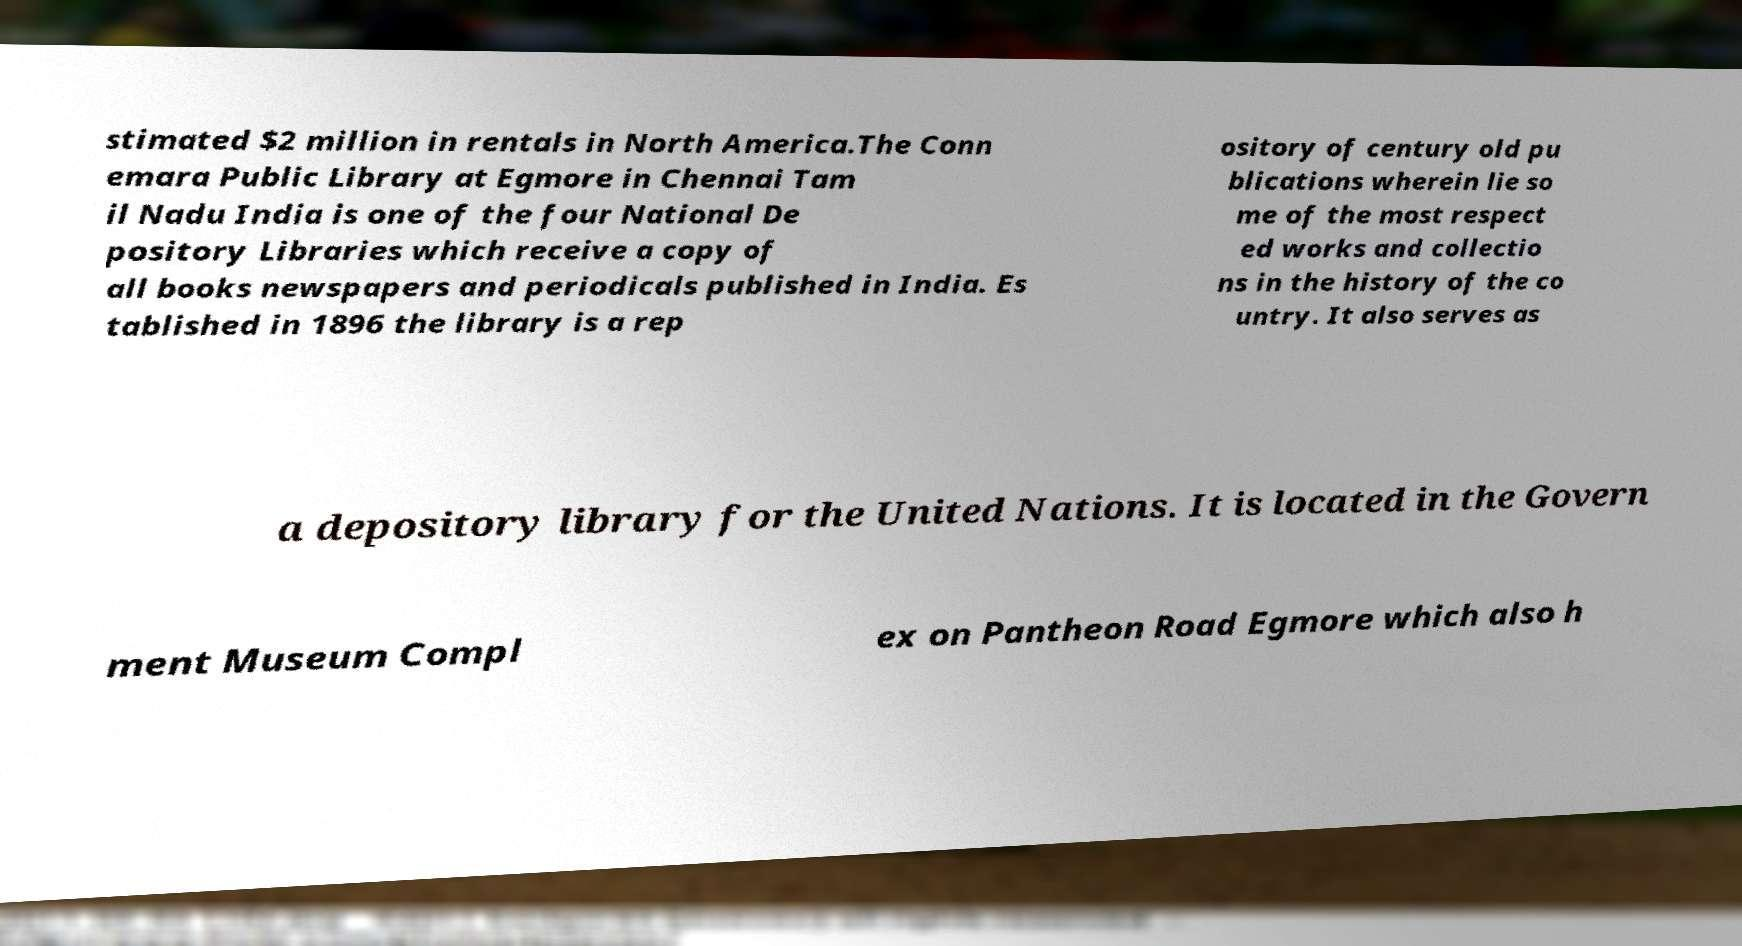Can you read and provide the text displayed in the image?This photo seems to have some interesting text. Can you extract and type it out for me? stimated $2 million in rentals in North America.The Conn emara Public Library at Egmore in Chennai Tam il Nadu India is one of the four National De pository Libraries which receive a copy of all books newspapers and periodicals published in India. Es tablished in 1896 the library is a rep ository of century old pu blications wherein lie so me of the most respect ed works and collectio ns in the history of the co untry. It also serves as a depository library for the United Nations. It is located in the Govern ment Museum Compl ex on Pantheon Road Egmore which also h 